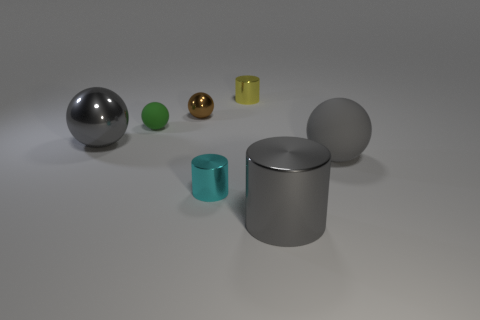What size is the gray metal thing that is the same shape as the tiny matte object?
Ensure brevity in your answer.  Large. What is the shape of the tiny yellow metal thing?
Provide a succinct answer. Cylinder. Do the small brown thing and the large gray thing in front of the gray matte ball have the same material?
Your answer should be very brief. Yes. How many shiny objects are big balls or small brown spheres?
Give a very brief answer. 2. There is a gray metal object that is in front of the large gray rubber ball; how big is it?
Keep it short and to the point. Large. There is a thing that is the same material as the green ball; what size is it?
Give a very brief answer. Large. How many cylinders have the same color as the large matte thing?
Make the answer very short. 1. Is there a green sphere?
Ensure brevity in your answer.  Yes. There is a small green thing; is it the same shape as the gray metal thing that is to the right of the tiny brown metal ball?
Make the answer very short. No. What is the color of the big object that is in front of the thing that is right of the big gray object that is in front of the tiny cyan object?
Offer a very short reply. Gray. 